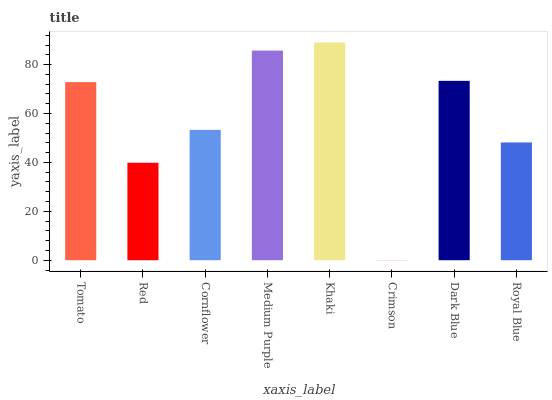Is Red the minimum?
Answer yes or no. No. Is Red the maximum?
Answer yes or no. No. Is Tomato greater than Red?
Answer yes or no. Yes. Is Red less than Tomato?
Answer yes or no. Yes. Is Red greater than Tomato?
Answer yes or no. No. Is Tomato less than Red?
Answer yes or no. No. Is Tomato the high median?
Answer yes or no. Yes. Is Cornflower the low median?
Answer yes or no. Yes. Is Dark Blue the high median?
Answer yes or no. No. Is Crimson the low median?
Answer yes or no. No. 